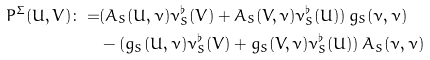<formula> <loc_0><loc_0><loc_500><loc_500>P ^ { \Sigma } ( U , V ) \colon = & ( A _ { S } ( U , \nu ) \nu _ { S } ^ { \flat } ( V ) + A _ { S } ( V , \nu ) \nu _ { S } ^ { \flat } ( U ) ) \, g _ { S } ( \nu , \nu ) \\ & - ( g _ { S } ( U , \nu ) \nu _ { S } ^ { \flat } ( V ) + g _ { S } ( V , \nu ) \nu _ { S } ^ { \flat } ( U ) ) \, A _ { S } ( \nu , \nu )</formula> 